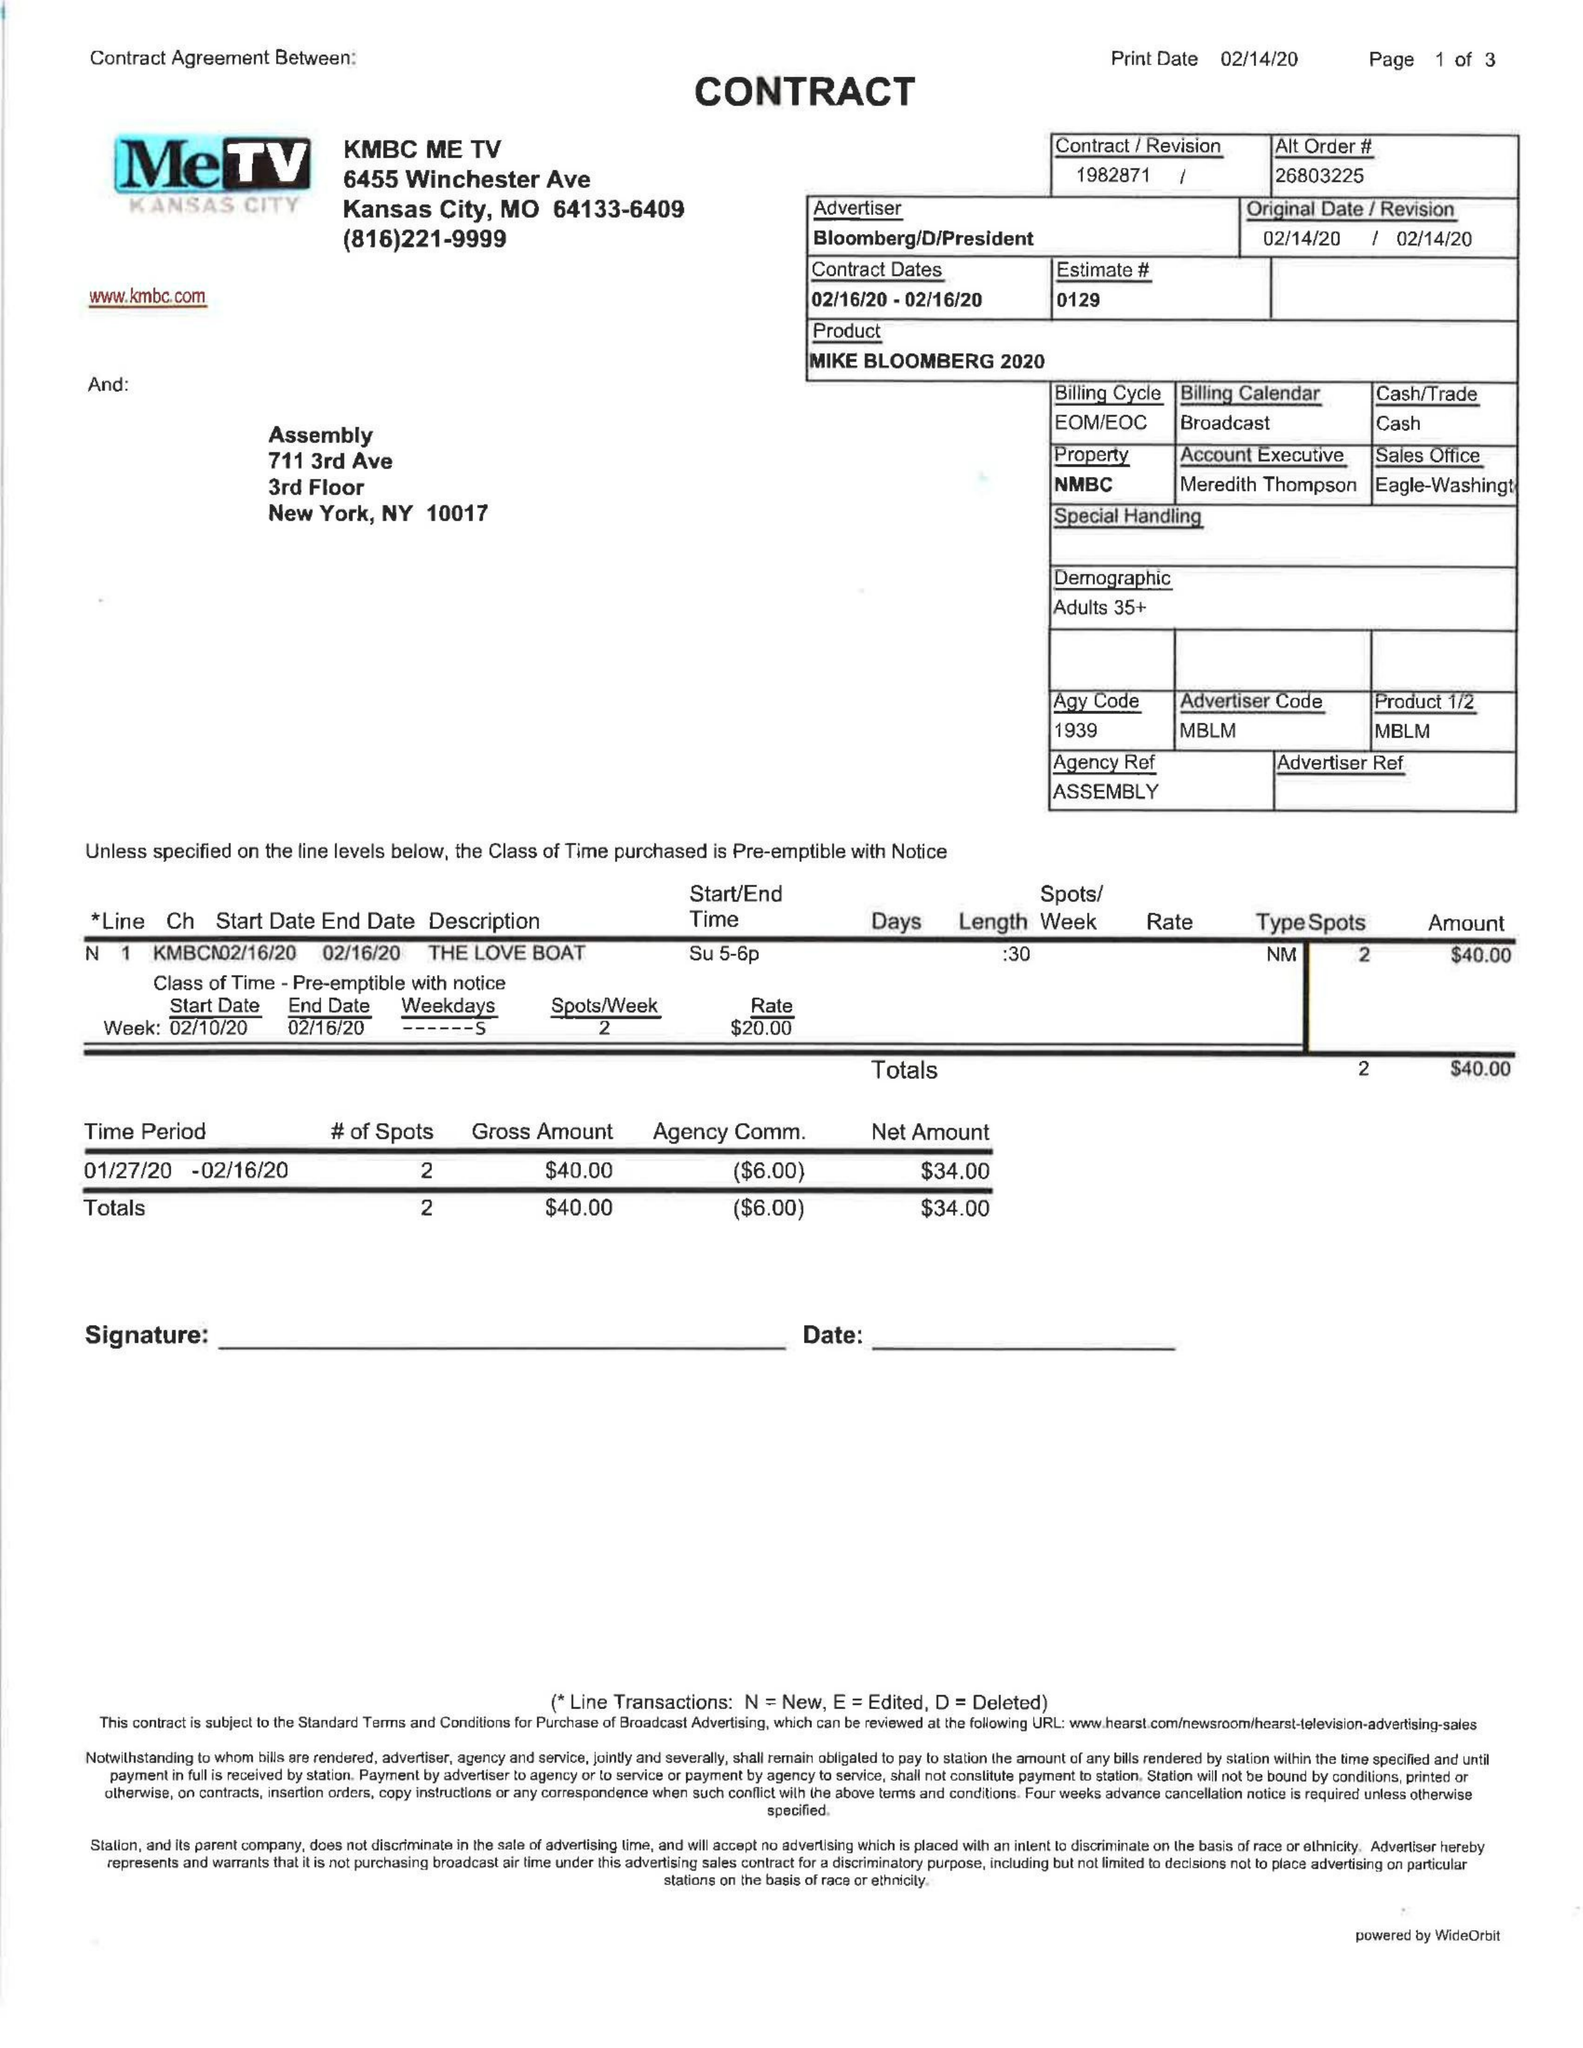What is the value for the advertiser?
Answer the question using a single word or phrase. BLOOMBERG/D/PRESIDENT 